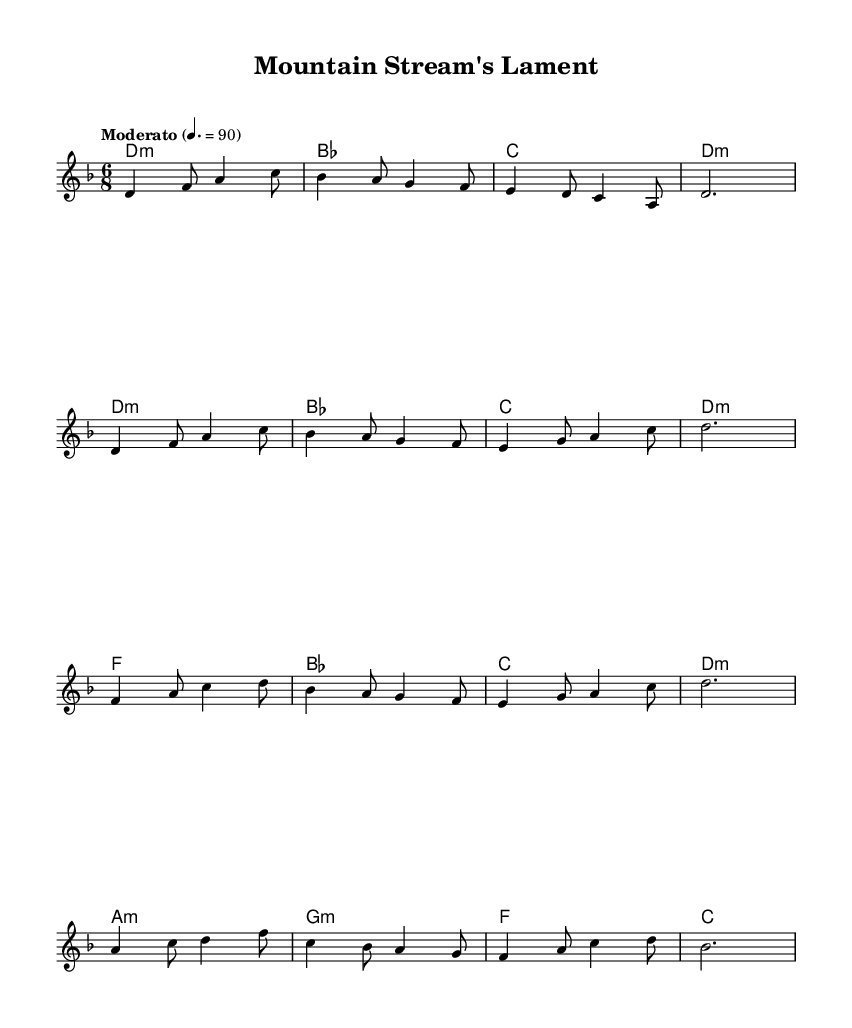What is the key signature of this music? The key signature is D minor, which has one flat (B flat).
Answer: D minor What is the time signature of this piece? The time signature is 6/8, indicating six eighth notes per measure.
Answer: 6/8 What is the indicated tempo of the music? The tempo marking indicates a speed of 90 beats per minute for the quarter note.
Answer: 90 How many measures are in the chorus section? The chorus contains four measures, as seen in the grouping of notes labeled with the Chorus identifiers.
Answer: 4 Which chords are used in the bridge section? The chords in the bridge section are A minor, G minor, F major, and C major, following the chord symbols laid out in the harmonies.
Answer: A minor, G minor, F major, C major What is the main theme or concept explored in this piece? The main theme revolves around environmental conservation, reflecting the fusion of Neo-soul and Appalachian folk influences, as indicated in the context.
Answer: Environmental conservation What type of musical fusion does this piece represent? This music represents a fusion of Neo-soul and Appalachian folk, blending elements from both genres in its structure and themes.
Answer: Neo-soul and Appalachian folk 